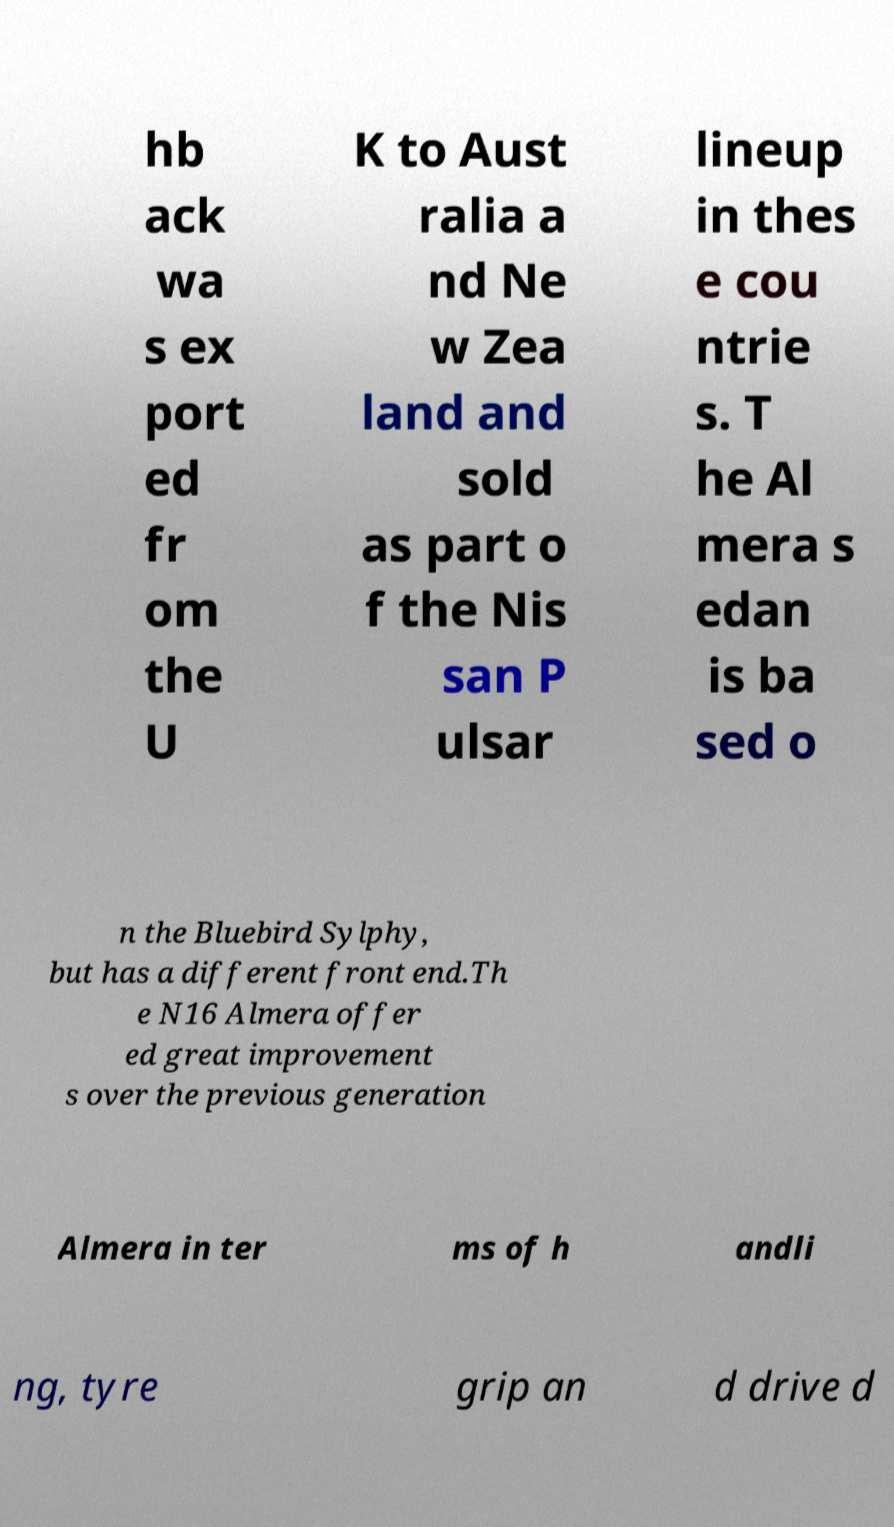Can you read and provide the text displayed in the image?This photo seems to have some interesting text. Can you extract and type it out for me? hb ack wa s ex port ed fr om the U K to Aust ralia a nd Ne w Zea land and sold as part o f the Nis san P ulsar lineup in thes e cou ntrie s. T he Al mera s edan is ba sed o n the Bluebird Sylphy, but has a different front end.Th e N16 Almera offer ed great improvement s over the previous generation Almera in ter ms of h andli ng, tyre grip an d drive d 